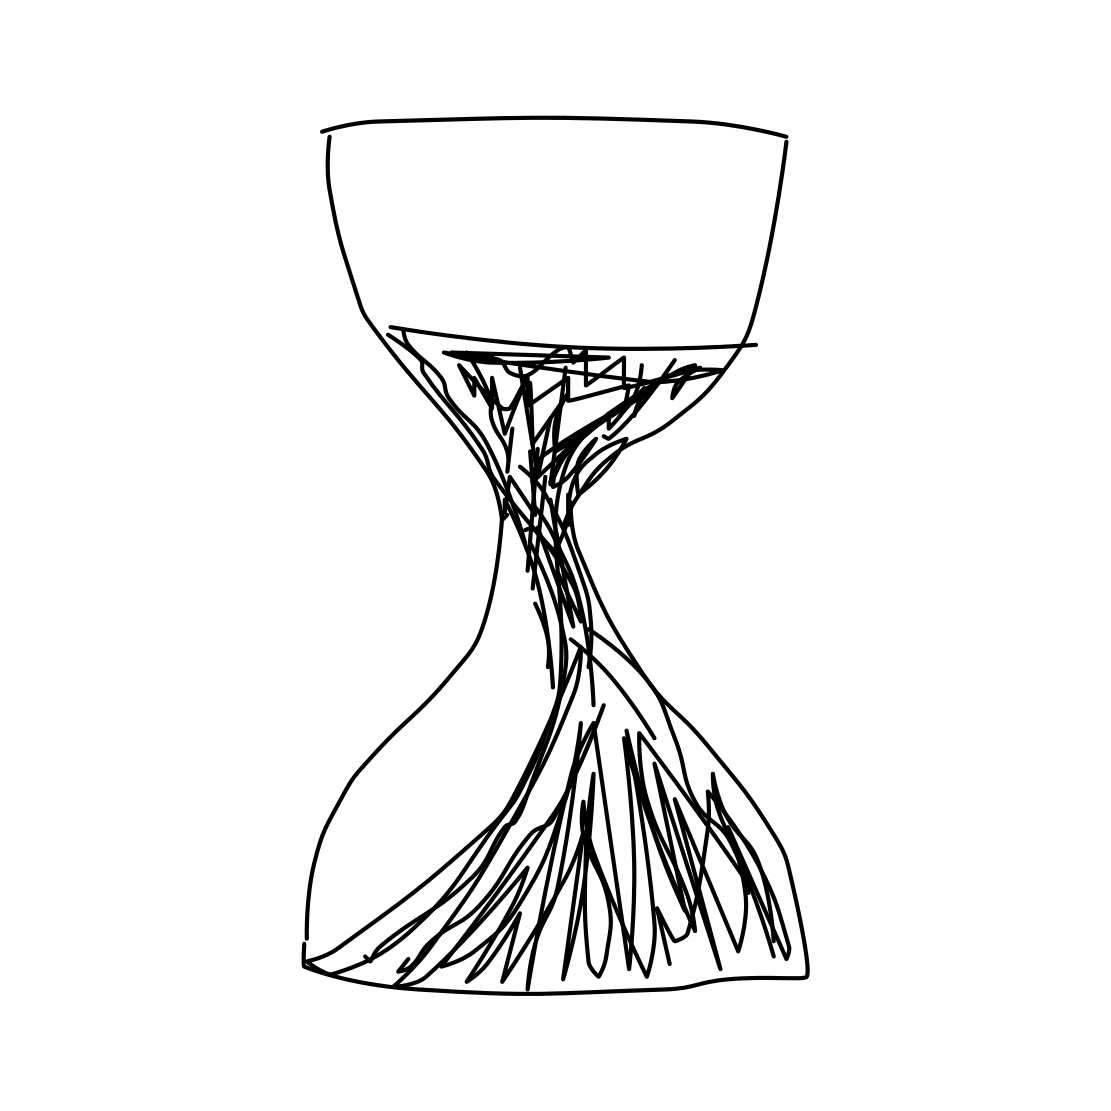Is the hourglass half full or half empty, and what does that say? The drawing presents the hourglass in a state that could be interpreted as half full or half empty. This ambiguity allows for a metaphorical discussion - an optimist may see it as half full, symbolizing potential and future opportunities, while a pessimist may see it as half empty, representing time that has irretrievably passed. 